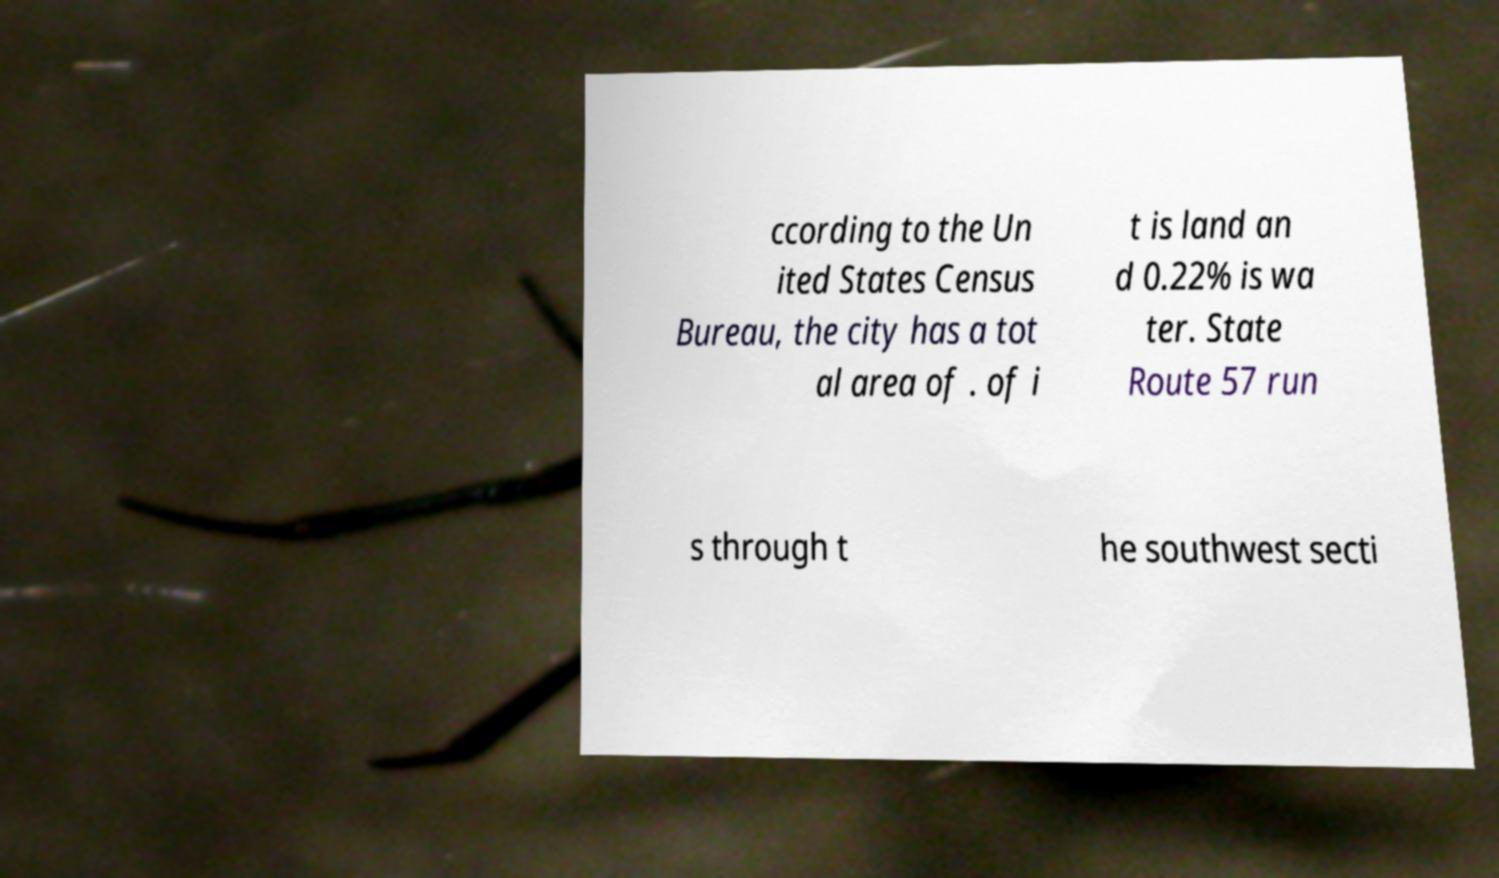Could you extract and type out the text from this image? ccording to the Un ited States Census Bureau, the city has a tot al area of . of i t is land an d 0.22% is wa ter. State Route 57 run s through t he southwest secti 